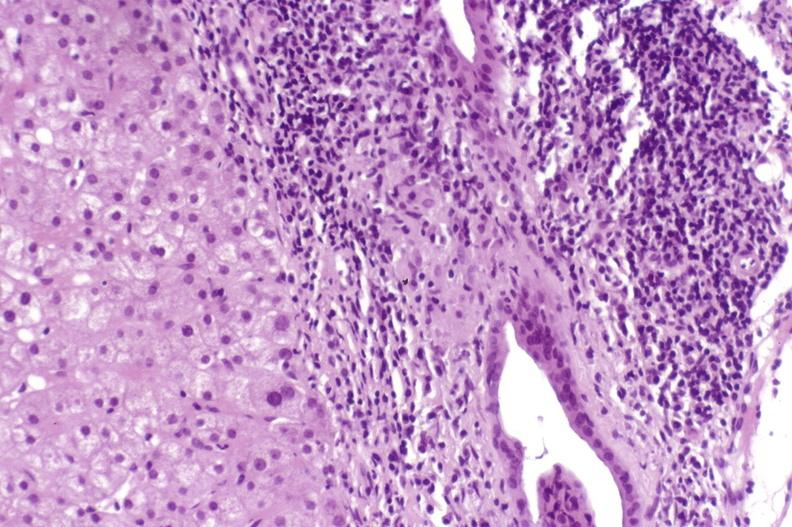does this image show primary biliary cirrhosis?
Answer the question using a single word or phrase. Yes 